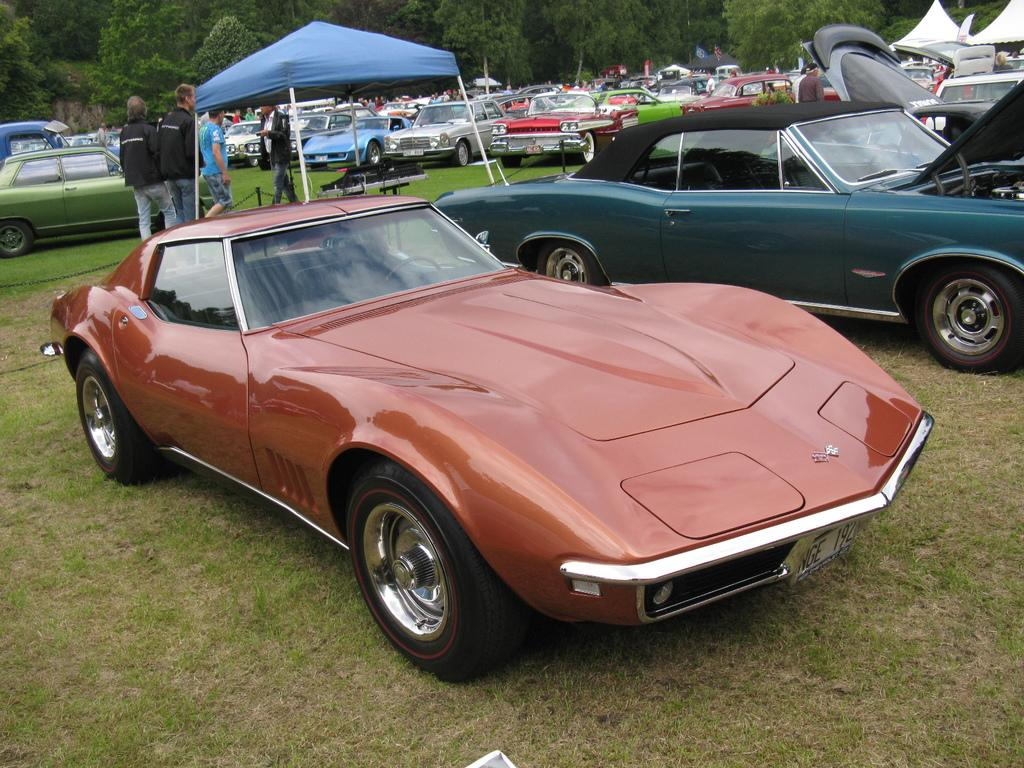What type of vehicles can be seen in the image? There are cars in the image. Who or what else is present in the image? There are people and a tent in the image. Can you describe the black object on the ground? There is a black object on the ground in the image. What can be seen in the background of the image? There are trees in the background of the image. How many chickens are sitting on the cars in the image? There are no chickens present in the image. What key is used to unlock the tent in the image? There is no key mentioned or depicted in the image. 